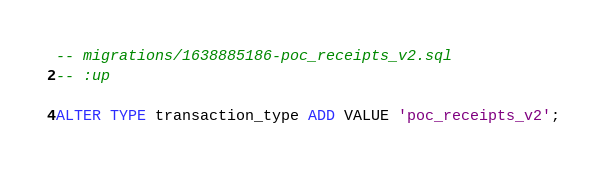<code> <loc_0><loc_0><loc_500><loc_500><_SQL_>-- migrations/1638885186-poc_receipts_v2.sql
-- :up

ALTER TYPE transaction_type ADD VALUE 'poc_receipts_v2';
</code> 